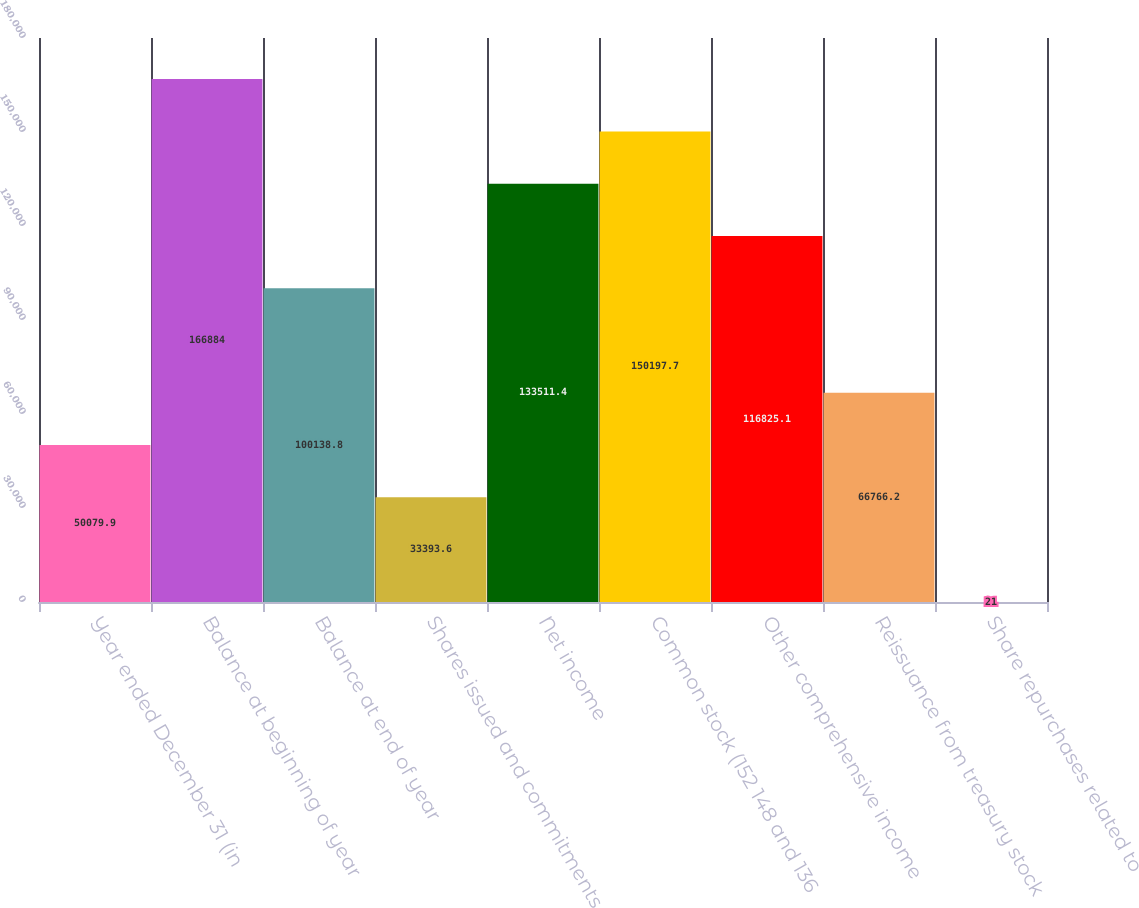Convert chart to OTSL. <chart><loc_0><loc_0><loc_500><loc_500><bar_chart><fcel>Year ended December 31 (in<fcel>Balance at beginning of year<fcel>Balance at end of year<fcel>Shares issued and commitments<fcel>Net income<fcel>Common stock (152 148 and 136<fcel>Other comprehensive income<fcel>Reissuance from treasury stock<fcel>Share repurchases related to<nl><fcel>50079.9<fcel>166884<fcel>100139<fcel>33393.6<fcel>133511<fcel>150198<fcel>116825<fcel>66766.2<fcel>21<nl></chart> 